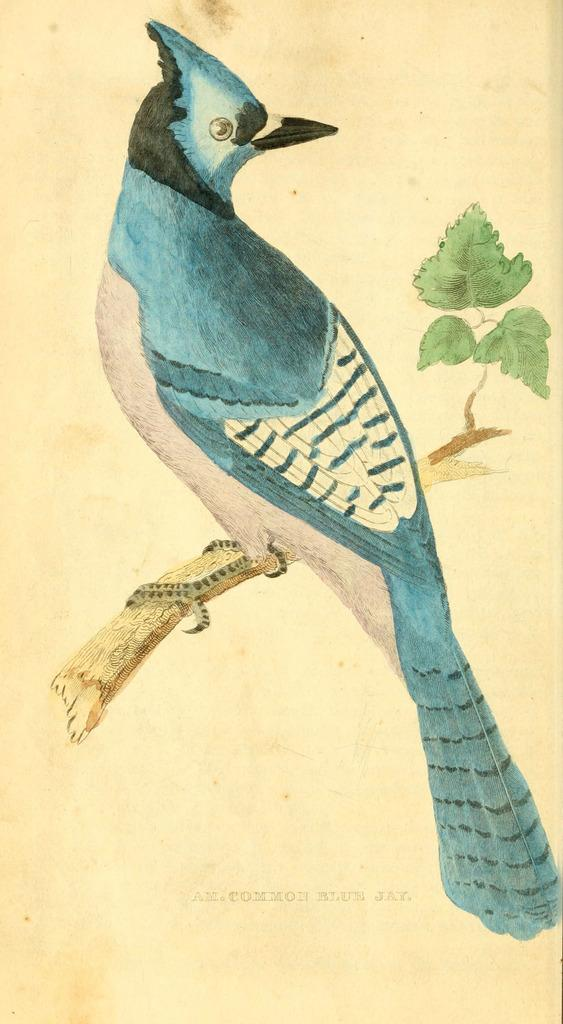What is the main subject of the image? There is a painting in the image. What is depicted in the painting? The painting depicts a bird. Where is the bird located in the painting? The bird is sitting on a tree stem in the painting. How many yaks are pulling the bird in the painting? There are no yaks present in the painting, and the bird is not being pulled by any animals. 